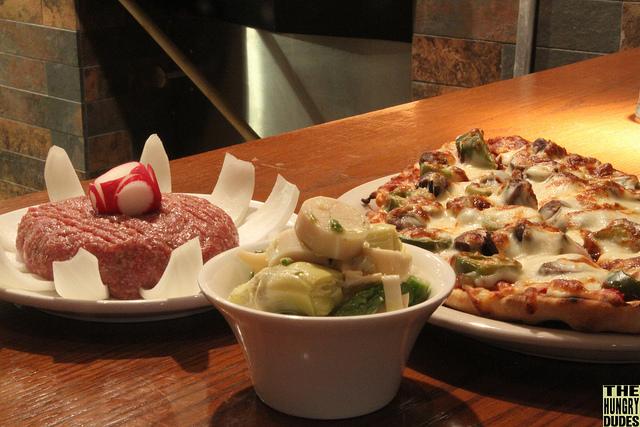Has the hamburger been cooked yet?
Give a very brief answer. No. Is this from a restaurant?
Give a very brief answer. Yes. What  is in the white bowl?
Quick response, please. Vegetables. 